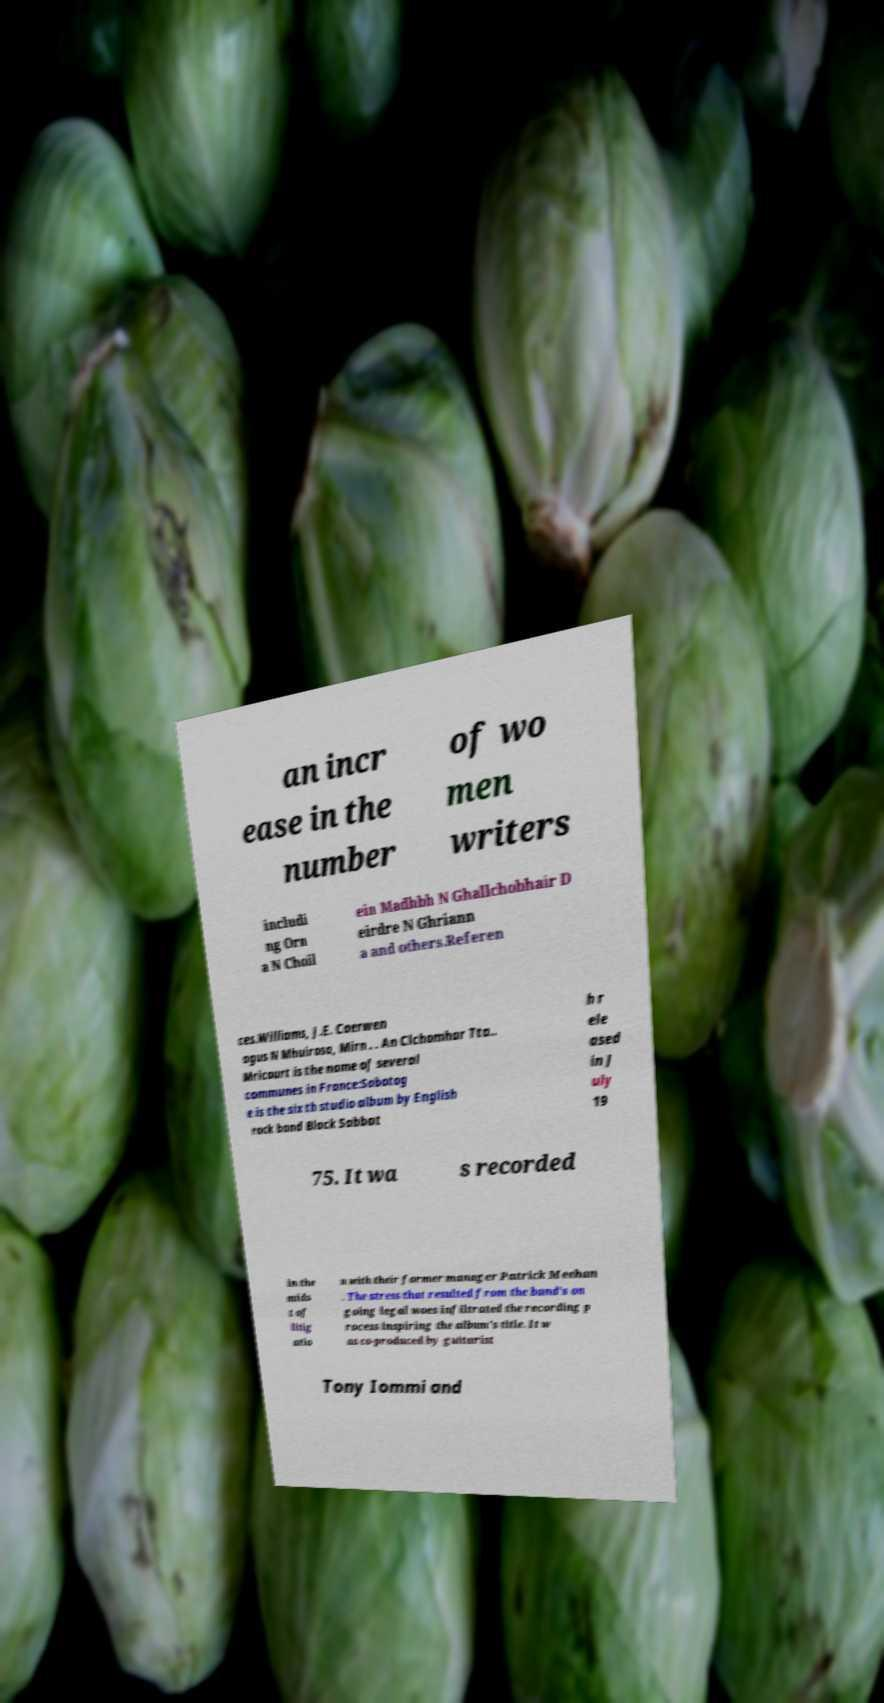Please identify and transcribe the text found in this image. an incr ease in the number of wo men writers includi ng Orn a N Choil ein Madhbh N Ghallchobhair D eirdre N Ghriann a and others.Referen ces.Williams, J.E. Caerwen agus N Mhuirosa, Mirn . . An Clchomhar Tta.. Mricourt is the name of several communes in France:Sabotag e is the sixth studio album by English rock band Black Sabbat h r ele ased in J uly 19 75. It wa s recorded in the mids t of litig atio n with their former manager Patrick Meehan . The stress that resulted from the band's on going legal woes infiltrated the recording p rocess inspiring the album's title. It w as co-produced by guitarist Tony Iommi and 